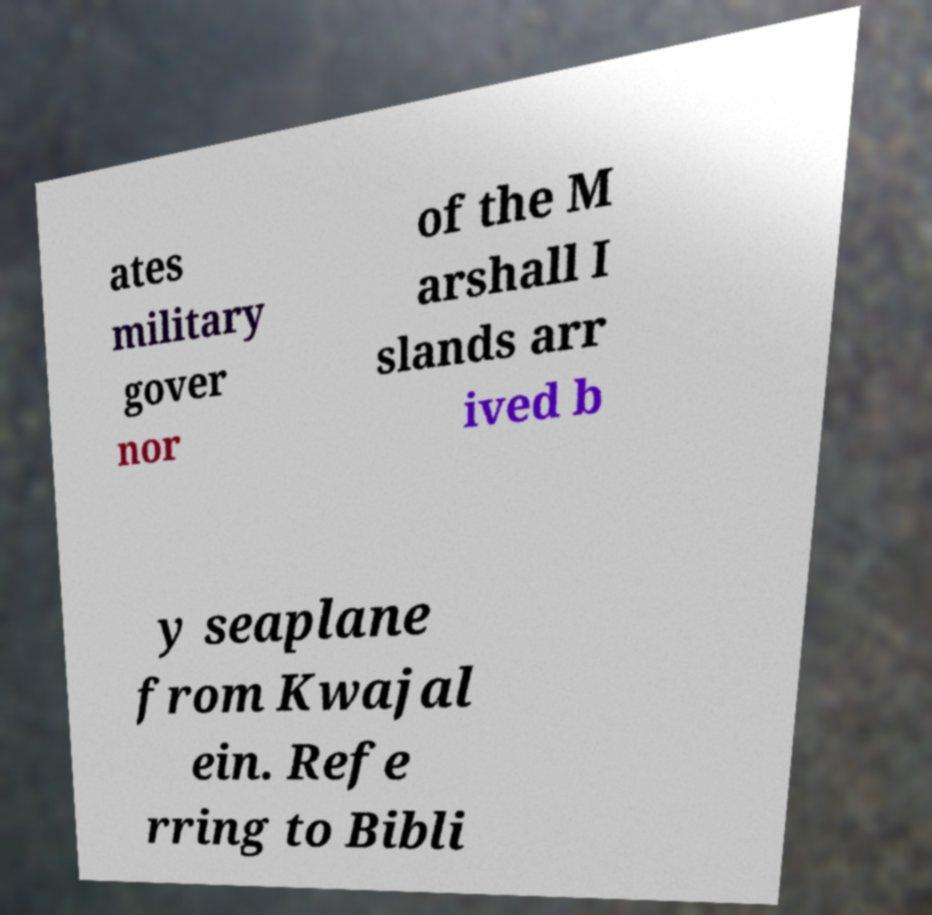Could you assist in decoding the text presented in this image and type it out clearly? ates military gover nor of the M arshall I slands arr ived b y seaplane from Kwajal ein. Refe rring to Bibli 